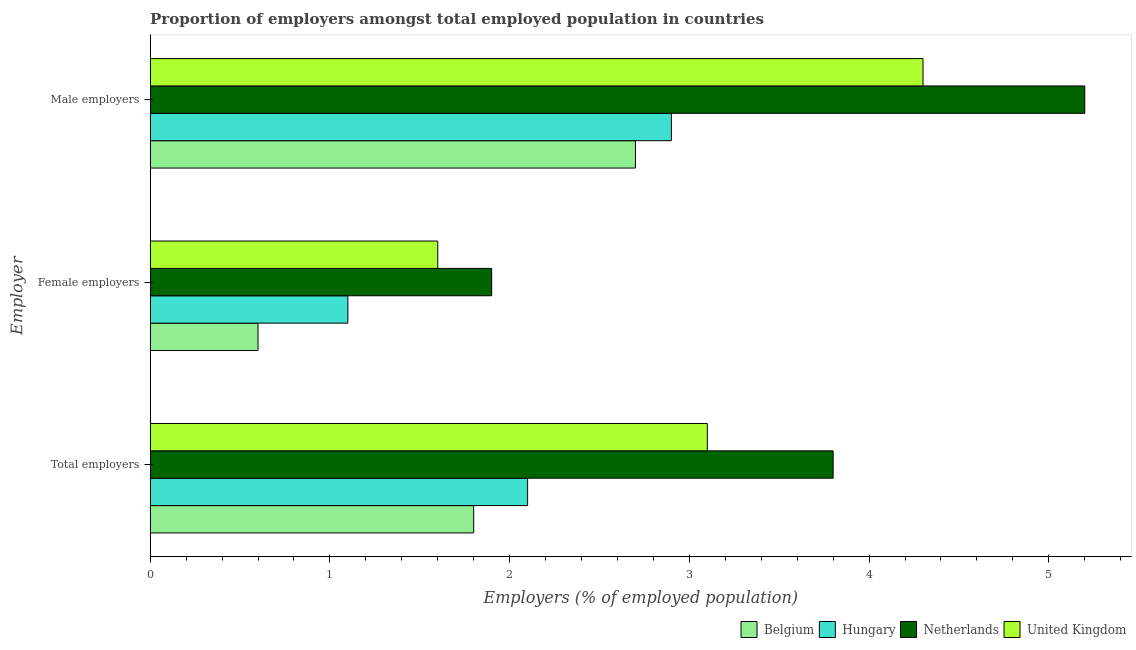How many groups of bars are there?
Provide a short and direct response. 3. Are the number of bars on each tick of the Y-axis equal?
Offer a very short reply. Yes. How many bars are there on the 2nd tick from the top?
Your response must be concise. 4. What is the label of the 1st group of bars from the top?
Your answer should be very brief. Male employers. What is the percentage of female employers in Belgium?
Your response must be concise. 0.6. Across all countries, what is the maximum percentage of male employers?
Offer a very short reply. 5.2. Across all countries, what is the minimum percentage of total employers?
Your response must be concise. 1.8. In which country was the percentage of total employers maximum?
Ensure brevity in your answer.  Netherlands. What is the total percentage of female employers in the graph?
Make the answer very short. 5.2. What is the difference between the percentage of male employers in Belgium and that in Hungary?
Your response must be concise. -0.2. What is the difference between the percentage of total employers in Belgium and the percentage of female employers in United Kingdom?
Keep it short and to the point. 0.2. What is the average percentage of male employers per country?
Offer a terse response. 3.78. What is the difference between the percentage of female employers and percentage of male employers in Belgium?
Give a very brief answer. -2.1. In how many countries, is the percentage of total employers greater than 3.4 %?
Your answer should be very brief. 1. What is the ratio of the percentage of male employers in Netherlands to that in United Kingdom?
Keep it short and to the point. 1.21. Is the percentage of total employers in Netherlands less than that in Belgium?
Offer a terse response. No. Is the difference between the percentage of female employers in Belgium and Netherlands greater than the difference between the percentage of total employers in Belgium and Netherlands?
Provide a short and direct response. Yes. What is the difference between the highest and the second highest percentage of total employers?
Give a very brief answer. 0.7. In how many countries, is the percentage of male employers greater than the average percentage of male employers taken over all countries?
Offer a terse response. 2. What does the 3rd bar from the top in Male employers represents?
Keep it short and to the point. Hungary. What does the 1st bar from the bottom in Male employers represents?
Your answer should be very brief. Belgium. Is it the case that in every country, the sum of the percentage of total employers and percentage of female employers is greater than the percentage of male employers?
Provide a short and direct response. No. Are all the bars in the graph horizontal?
Your response must be concise. Yes. How many countries are there in the graph?
Give a very brief answer. 4. Are the values on the major ticks of X-axis written in scientific E-notation?
Your response must be concise. No. Does the graph contain any zero values?
Your answer should be compact. No. How many legend labels are there?
Provide a short and direct response. 4. How are the legend labels stacked?
Provide a succinct answer. Horizontal. What is the title of the graph?
Make the answer very short. Proportion of employers amongst total employed population in countries. Does "Turkmenistan" appear as one of the legend labels in the graph?
Offer a terse response. No. What is the label or title of the X-axis?
Make the answer very short. Employers (% of employed population). What is the label or title of the Y-axis?
Your answer should be compact. Employer. What is the Employers (% of employed population) in Belgium in Total employers?
Ensure brevity in your answer.  1.8. What is the Employers (% of employed population) in Hungary in Total employers?
Provide a succinct answer. 2.1. What is the Employers (% of employed population) of Netherlands in Total employers?
Give a very brief answer. 3.8. What is the Employers (% of employed population) of United Kingdom in Total employers?
Offer a very short reply. 3.1. What is the Employers (% of employed population) of Belgium in Female employers?
Give a very brief answer. 0.6. What is the Employers (% of employed population) in Hungary in Female employers?
Offer a very short reply. 1.1. What is the Employers (% of employed population) of Netherlands in Female employers?
Offer a very short reply. 1.9. What is the Employers (% of employed population) of United Kingdom in Female employers?
Your answer should be very brief. 1.6. What is the Employers (% of employed population) of Belgium in Male employers?
Offer a very short reply. 2.7. What is the Employers (% of employed population) in Hungary in Male employers?
Offer a very short reply. 2.9. What is the Employers (% of employed population) of Netherlands in Male employers?
Your answer should be very brief. 5.2. What is the Employers (% of employed population) in United Kingdom in Male employers?
Provide a succinct answer. 4.3. Across all Employer, what is the maximum Employers (% of employed population) in Belgium?
Ensure brevity in your answer.  2.7. Across all Employer, what is the maximum Employers (% of employed population) of Hungary?
Offer a terse response. 2.9. Across all Employer, what is the maximum Employers (% of employed population) of Netherlands?
Your answer should be very brief. 5.2. Across all Employer, what is the maximum Employers (% of employed population) in United Kingdom?
Your answer should be compact. 4.3. Across all Employer, what is the minimum Employers (% of employed population) of Belgium?
Ensure brevity in your answer.  0.6. Across all Employer, what is the minimum Employers (% of employed population) in Hungary?
Keep it short and to the point. 1.1. Across all Employer, what is the minimum Employers (% of employed population) in Netherlands?
Offer a terse response. 1.9. Across all Employer, what is the minimum Employers (% of employed population) of United Kingdom?
Offer a terse response. 1.6. What is the total Employers (% of employed population) in Belgium in the graph?
Provide a short and direct response. 5.1. What is the difference between the Employers (% of employed population) of Hungary in Total employers and that in Female employers?
Keep it short and to the point. 1. What is the difference between the Employers (% of employed population) of Netherlands in Total employers and that in Female employers?
Offer a terse response. 1.9. What is the difference between the Employers (% of employed population) in United Kingdom in Total employers and that in Female employers?
Your response must be concise. 1.5. What is the difference between the Employers (% of employed population) of Netherlands in Total employers and that in Male employers?
Provide a short and direct response. -1.4. What is the difference between the Employers (% of employed population) in United Kingdom in Total employers and that in Male employers?
Keep it short and to the point. -1.2. What is the difference between the Employers (% of employed population) in United Kingdom in Female employers and that in Male employers?
Your response must be concise. -2.7. What is the difference between the Employers (% of employed population) of Belgium in Total employers and the Employers (% of employed population) of Hungary in Female employers?
Offer a very short reply. 0.7. What is the difference between the Employers (% of employed population) of Belgium in Total employers and the Employers (% of employed population) of Netherlands in Female employers?
Provide a succinct answer. -0.1. What is the difference between the Employers (% of employed population) of Hungary in Total employers and the Employers (% of employed population) of Netherlands in Female employers?
Make the answer very short. 0.2. What is the difference between the Employers (% of employed population) of Hungary in Total employers and the Employers (% of employed population) of United Kingdom in Female employers?
Offer a terse response. 0.5. What is the difference between the Employers (% of employed population) of Belgium in Total employers and the Employers (% of employed population) of Hungary in Male employers?
Your answer should be very brief. -1.1. What is the difference between the Employers (% of employed population) in Belgium in Total employers and the Employers (% of employed population) in Netherlands in Male employers?
Offer a very short reply. -3.4. What is the difference between the Employers (% of employed population) of Hungary in Total employers and the Employers (% of employed population) of United Kingdom in Male employers?
Your answer should be compact. -2.2. What is the difference between the Employers (% of employed population) in Netherlands in Total employers and the Employers (% of employed population) in United Kingdom in Male employers?
Ensure brevity in your answer.  -0.5. What is the difference between the Employers (% of employed population) of Belgium in Female employers and the Employers (% of employed population) of United Kingdom in Male employers?
Give a very brief answer. -3.7. What is the difference between the Employers (% of employed population) of Hungary in Female employers and the Employers (% of employed population) of United Kingdom in Male employers?
Give a very brief answer. -3.2. What is the average Employers (% of employed population) of Belgium per Employer?
Give a very brief answer. 1.7. What is the average Employers (% of employed population) of Hungary per Employer?
Provide a succinct answer. 2.03. What is the average Employers (% of employed population) in Netherlands per Employer?
Make the answer very short. 3.63. What is the difference between the Employers (% of employed population) of Belgium and Employers (% of employed population) of Netherlands in Total employers?
Keep it short and to the point. -2. What is the difference between the Employers (% of employed population) of Hungary and Employers (% of employed population) of United Kingdom in Total employers?
Your response must be concise. -1. What is the difference between the Employers (% of employed population) in Netherlands and Employers (% of employed population) in United Kingdom in Total employers?
Your response must be concise. 0.7. What is the difference between the Employers (% of employed population) of Belgium and Employers (% of employed population) of United Kingdom in Female employers?
Offer a very short reply. -1. What is the difference between the Employers (% of employed population) of Hungary and Employers (% of employed population) of Netherlands in Female employers?
Your answer should be very brief. -0.8. What is the difference between the Employers (% of employed population) in Hungary and Employers (% of employed population) in United Kingdom in Female employers?
Make the answer very short. -0.5. What is the difference between the Employers (% of employed population) in Netherlands and Employers (% of employed population) in United Kingdom in Female employers?
Ensure brevity in your answer.  0.3. What is the difference between the Employers (% of employed population) of Hungary and Employers (% of employed population) of Netherlands in Male employers?
Ensure brevity in your answer.  -2.3. What is the difference between the Employers (% of employed population) of Hungary and Employers (% of employed population) of United Kingdom in Male employers?
Keep it short and to the point. -1.4. What is the ratio of the Employers (% of employed population) in Belgium in Total employers to that in Female employers?
Ensure brevity in your answer.  3. What is the ratio of the Employers (% of employed population) in Hungary in Total employers to that in Female employers?
Your answer should be very brief. 1.91. What is the ratio of the Employers (% of employed population) of Netherlands in Total employers to that in Female employers?
Give a very brief answer. 2. What is the ratio of the Employers (% of employed population) of United Kingdom in Total employers to that in Female employers?
Keep it short and to the point. 1.94. What is the ratio of the Employers (% of employed population) of Hungary in Total employers to that in Male employers?
Offer a very short reply. 0.72. What is the ratio of the Employers (% of employed population) of Netherlands in Total employers to that in Male employers?
Offer a terse response. 0.73. What is the ratio of the Employers (% of employed population) in United Kingdom in Total employers to that in Male employers?
Your answer should be compact. 0.72. What is the ratio of the Employers (% of employed population) in Belgium in Female employers to that in Male employers?
Offer a terse response. 0.22. What is the ratio of the Employers (% of employed population) in Hungary in Female employers to that in Male employers?
Provide a succinct answer. 0.38. What is the ratio of the Employers (% of employed population) of Netherlands in Female employers to that in Male employers?
Give a very brief answer. 0.37. What is the ratio of the Employers (% of employed population) of United Kingdom in Female employers to that in Male employers?
Offer a terse response. 0.37. What is the difference between the highest and the second highest Employers (% of employed population) of United Kingdom?
Provide a succinct answer. 1.2. What is the difference between the highest and the lowest Employers (% of employed population) of Hungary?
Provide a succinct answer. 1.8. What is the difference between the highest and the lowest Employers (% of employed population) of Netherlands?
Provide a succinct answer. 3.3. 